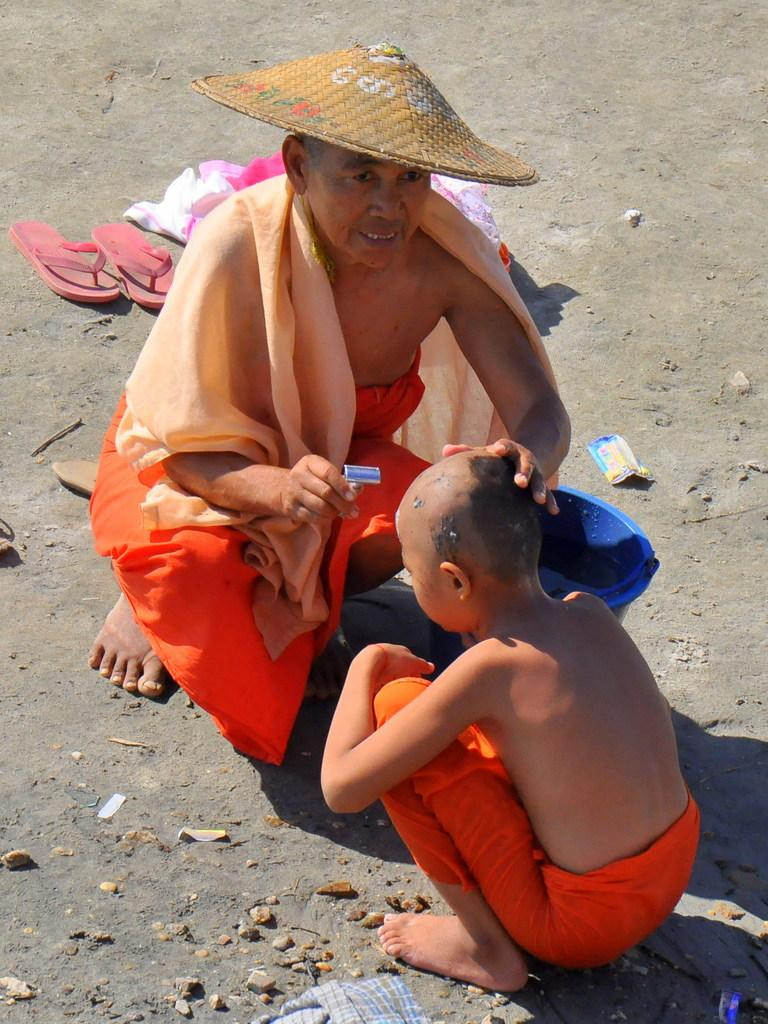How are the two persons in the image positioned? The two persons are in the squatting position. Can you identify the gender of one of the persons? One of the persons is a man. What is the man wearing on his head? The man is wearing a hat. What object is the man holding in his hand? The man is holding a blade in his hand. What type of footwear can be seen on the ground? There are slippers on the ground. What other objects are present on the ground? There are stones on the ground. What type of square object can be seen near the man in the image? There is no square object present near the man in the image. 